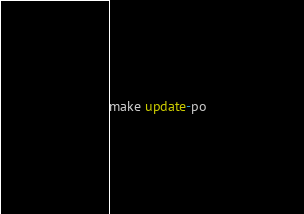<code> <loc_0><loc_0><loc_500><loc_500><_SQL_>make update-po
</code> 